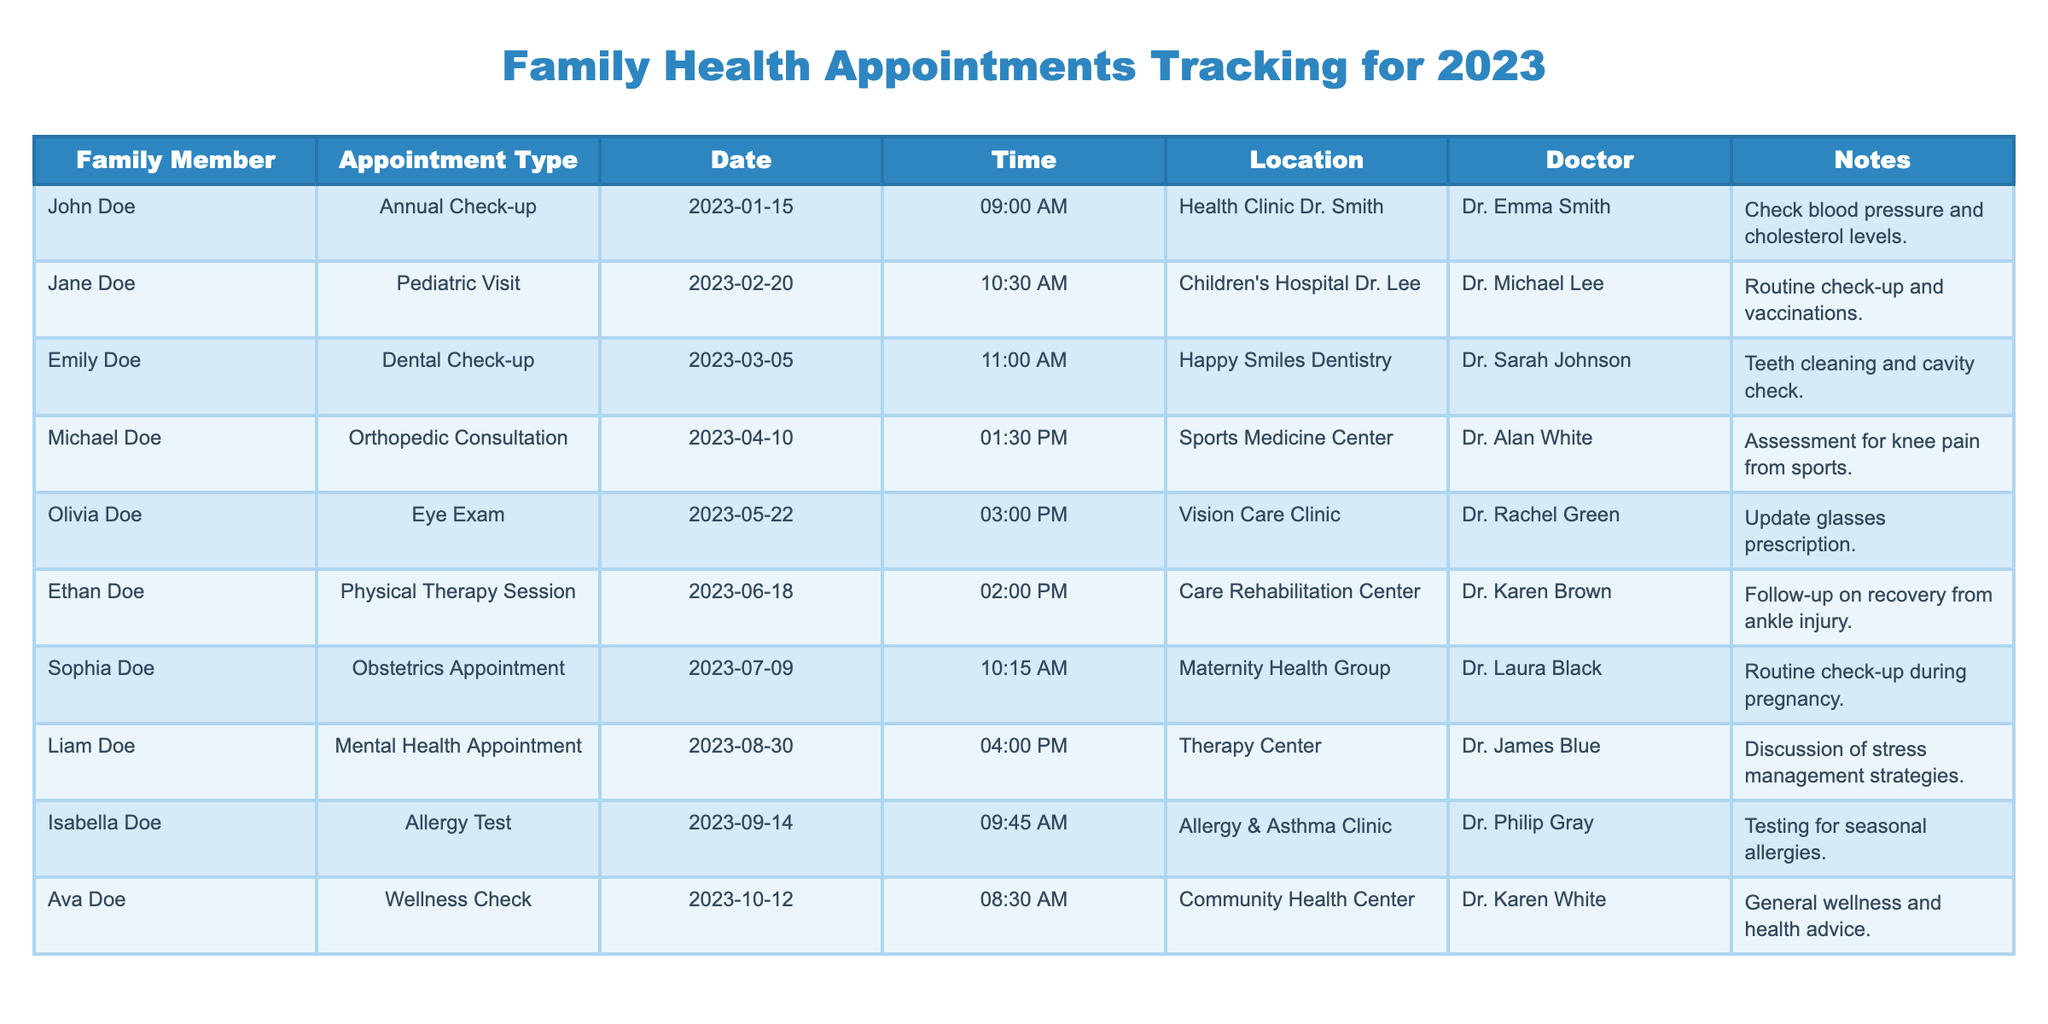What types of appointments are listed for family members in 2023? The table lists various types of appointments including Annual Check-up, Pediatric Visit, Dental Check-up, Orthopedic Consultation, Eye Exam, Physical Therapy Session, Obstetrics Appointment, Mental Health Appointment, Allergy Test, and Wellness Check.
Answer: Annual Check-up, Pediatric Visit, Dental Check-up, Orthopedic Consultation, Eye Exam, Physical Therapy Session, Obstetrics Appointment, Mental Health Appointment, Allergy Test, Wellness Check Who had a Pediatric Visit appointment and when? Jane Doe had a Pediatric Visit appointment scheduled for February 20, 2023.
Answer: Jane Doe, February 20, 2023 What is the date and time of the Eye Exam? The Eye Exam is scheduled for May 22, 2023, at 3:00 PM.
Answer: May 22, 2023, 3:00 PM How many appointments are listed for the Doe family members? There are 10 appointments listed in total for the Doe family members.
Answer: 10 Which family member has the earliest appointment date? John Doe has the earliest appointment on January 15, 2023, for an Annual Check-up.
Answer: John Doe, January 15, 2023 Is there any appointment scheduled for the month of August? Yes, there is a Mental Health Appointment scheduled for August 30, 2023.
Answer: Yes What is the total number of medical checkup appointments (including Annual Check-up, Pediatric Visit, and others)? There are 6 medical checkup appointments listed: Annual Check-up, Pediatric Visit, Eye Exam, Obstetrics Appointment, Allergy Test, and Wellness Check.
Answer: 6 What type of appointment does Isabella Doe have, and on what date? Isabella Doe has an Allergy Test scheduled on September 14, 2023.
Answer: Allergy Test, September 14, 2023 How many appointments involve a doctor focusing on mental health? There is 1 appointment involving a doctor focusing on mental health, which is Liam Doe's Mental Health Appointment.
Answer: 1 Which family member had an appointment related to sports? Michael Doe had an Orthopedic Consultation related to a sports injury.
Answer: Michael Doe What is the time difference between the Pediatric Visit and the Dental Check-up appointments? The Pediatric Visit is at 10:30 AM and the Dental Check-up is at 11:00 AM, which is a 30-minute difference.
Answer: 30 minutes 